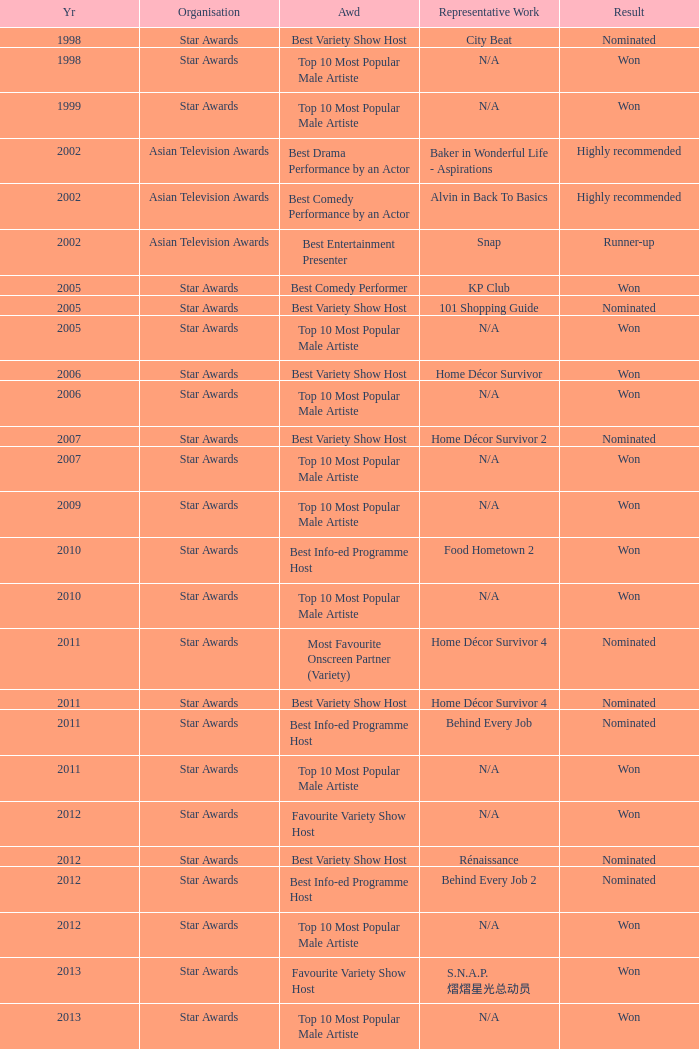Could you parse the entire table as a dict? {'header': ['Yr', 'Organisation', 'Awd', 'Representative Work', 'Result'], 'rows': [['1998', 'Star Awards', 'Best Variety Show Host', 'City Beat', 'Nominated'], ['1998', 'Star Awards', 'Top 10 Most Popular Male Artiste', 'N/A', 'Won'], ['1999', 'Star Awards', 'Top 10 Most Popular Male Artiste', 'N/A', 'Won'], ['2002', 'Asian Television Awards', 'Best Drama Performance by an Actor', 'Baker in Wonderful Life - Aspirations', 'Highly recommended'], ['2002', 'Asian Television Awards', 'Best Comedy Performance by an Actor', 'Alvin in Back To Basics', 'Highly recommended'], ['2002', 'Asian Television Awards', 'Best Entertainment Presenter', 'Snap', 'Runner-up'], ['2005', 'Star Awards', 'Best Comedy Performer', 'KP Club', 'Won'], ['2005', 'Star Awards', 'Best Variety Show Host', '101 Shopping Guide', 'Nominated'], ['2005', 'Star Awards', 'Top 10 Most Popular Male Artiste', 'N/A', 'Won'], ['2006', 'Star Awards', 'Best Variety Show Host', 'Home Décor Survivor', 'Won'], ['2006', 'Star Awards', 'Top 10 Most Popular Male Artiste', 'N/A', 'Won'], ['2007', 'Star Awards', 'Best Variety Show Host', 'Home Décor Survivor 2', 'Nominated'], ['2007', 'Star Awards', 'Top 10 Most Popular Male Artiste', 'N/A', 'Won'], ['2009', 'Star Awards', 'Top 10 Most Popular Male Artiste', 'N/A', 'Won'], ['2010', 'Star Awards', 'Best Info-ed Programme Host', 'Food Hometown 2', 'Won'], ['2010', 'Star Awards', 'Top 10 Most Popular Male Artiste', 'N/A', 'Won'], ['2011', 'Star Awards', 'Most Favourite Onscreen Partner (Variety)', 'Home Décor Survivor 4', 'Nominated'], ['2011', 'Star Awards', 'Best Variety Show Host', 'Home Décor Survivor 4', 'Nominated'], ['2011', 'Star Awards', 'Best Info-ed Programme Host', 'Behind Every Job', 'Nominated'], ['2011', 'Star Awards', 'Top 10 Most Popular Male Artiste', 'N/A', 'Won'], ['2012', 'Star Awards', 'Favourite Variety Show Host', 'N/A', 'Won'], ['2012', 'Star Awards', 'Best Variety Show Host', 'Rénaissance', 'Nominated'], ['2012', 'Star Awards', 'Best Info-ed Programme Host', 'Behind Every Job 2', 'Nominated'], ['2012', 'Star Awards', 'Top 10 Most Popular Male Artiste', 'N/A', 'Won'], ['2013', 'Star Awards', 'Favourite Variety Show Host', 'S.N.A.P. 熠熠星光总动员', 'Won'], ['2013', 'Star Awards', 'Top 10 Most Popular Male Artiste', 'N/A', 'Won'], ['2013', 'Star Awards', 'Best Info-Ed Programme Host', 'Makan Unlimited', 'Nominated'], ['2013', 'Star Awards', 'Best Variety Show Host', 'Jobs Around The World', 'Nominated']]} What is the name of the Representative Work in a year later than 2005 with a Result of nominated, and an Award of best variety show host? Home Décor Survivor 2, Home Décor Survivor 4, Rénaissance, Jobs Around The World. 